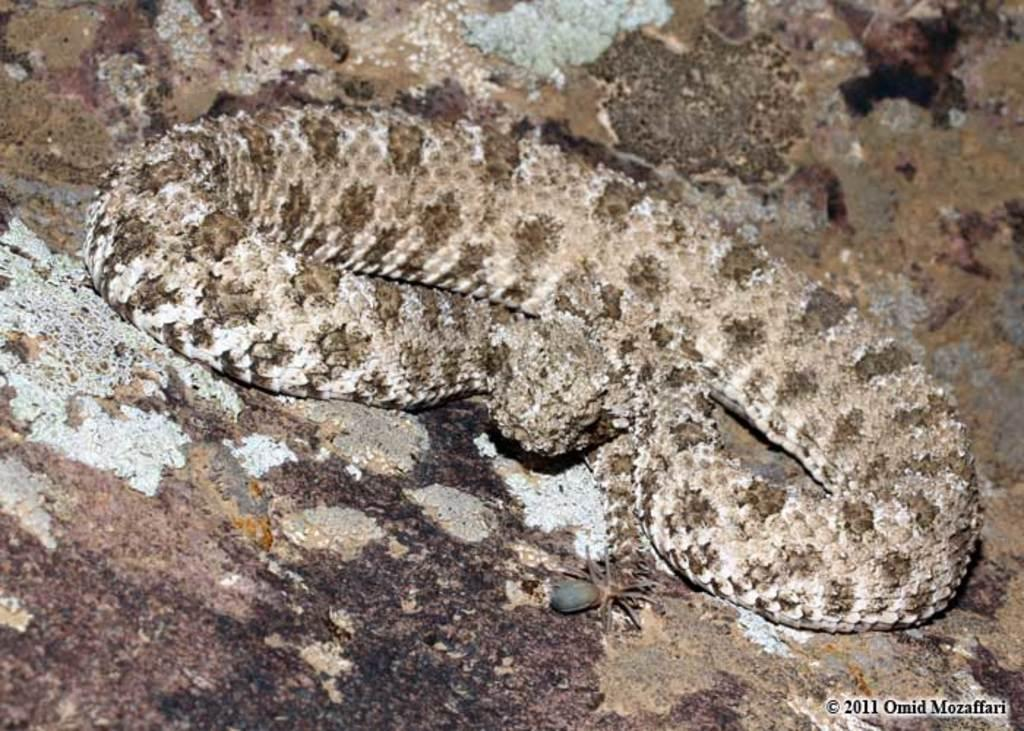What type of animal can be seen in the image? There is a snake in the image. What other creatures are present in the image? There are spiders on the ground in the image. How many people are sitting on the tramp in the image? There is no tramp present in the image. What type of breath can be seen coming from the snake in the image? Snakes do not have lungs or the ability to breathe in the same way as humans, so there is no breath visible in the image. 